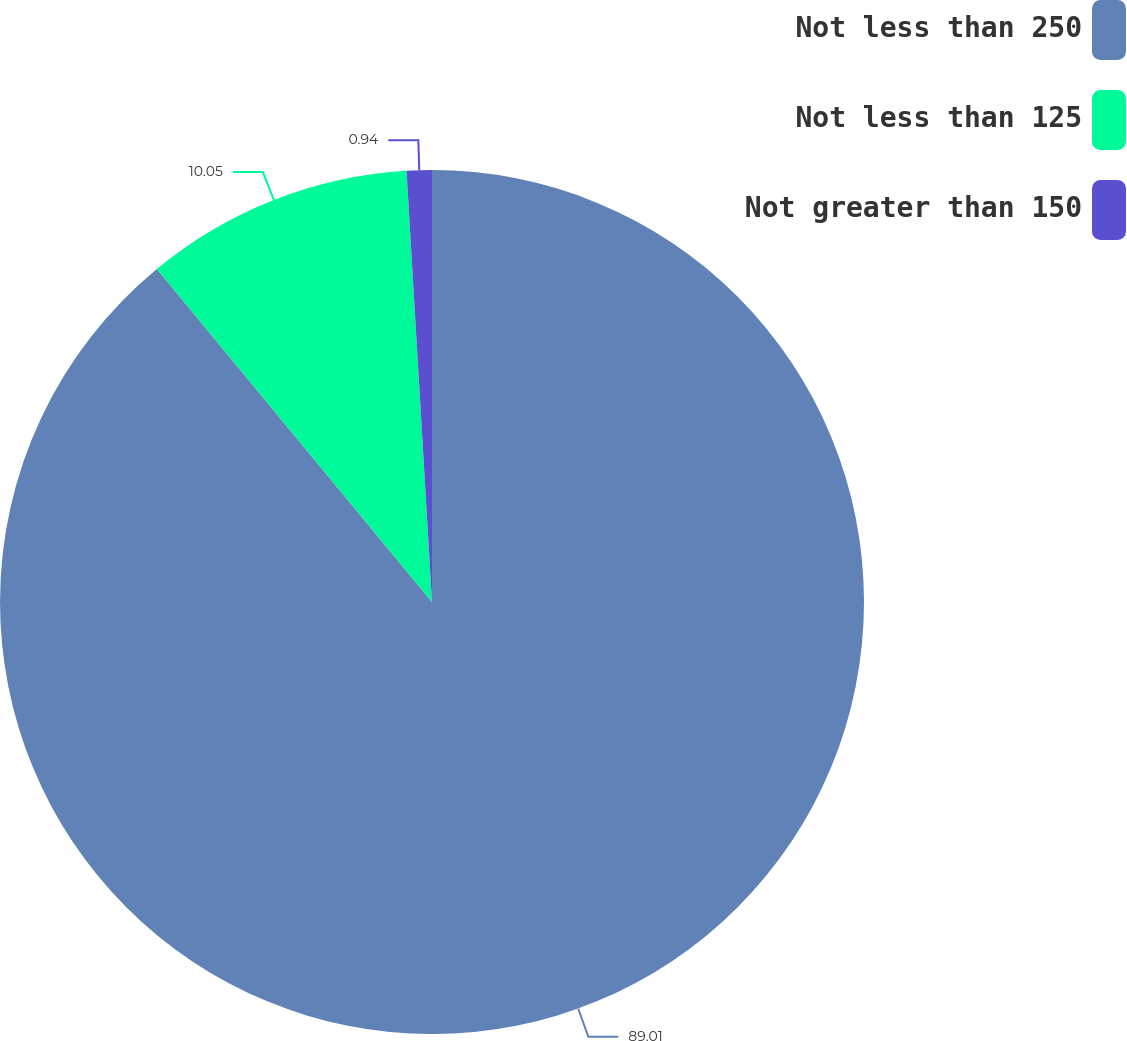Convert chart to OTSL. <chart><loc_0><loc_0><loc_500><loc_500><pie_chart><fcel>Not less than 250<fcel>Not less than 125<fcel>Not greater than 150<nl><fcel>89.01%<fcel>10.05%<fcel>0.94%<nl></chart> 